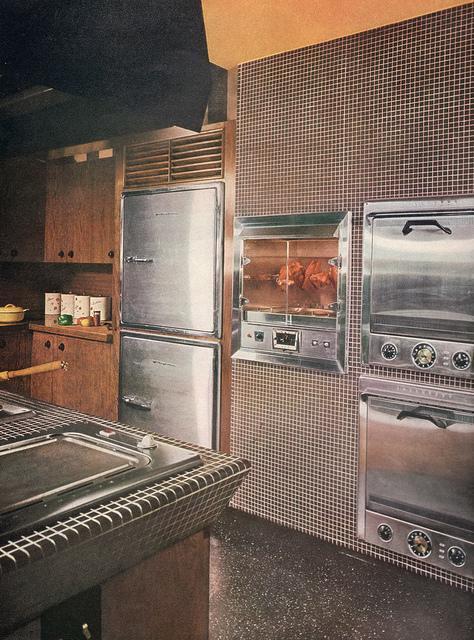How many ovens are in the picture?
Give a very brief answer. 2. 